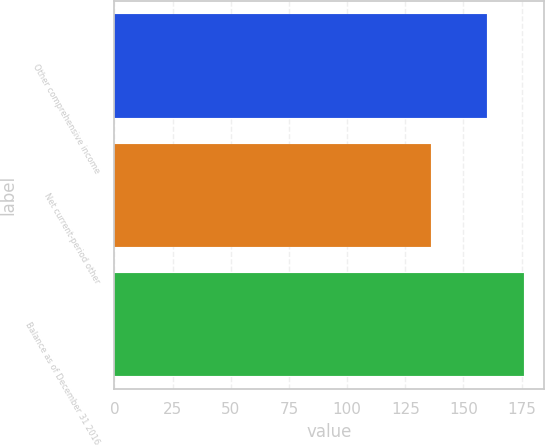<chart> <loc_0><loc_0><loc_500><loc_500><bar_chart><fcel>Other comprehensive income<fcel>Net current-period other<fcel>Balance as of December 31 2016<nl><fcel>160<fcel>136<fcel>176<nl></chart> 